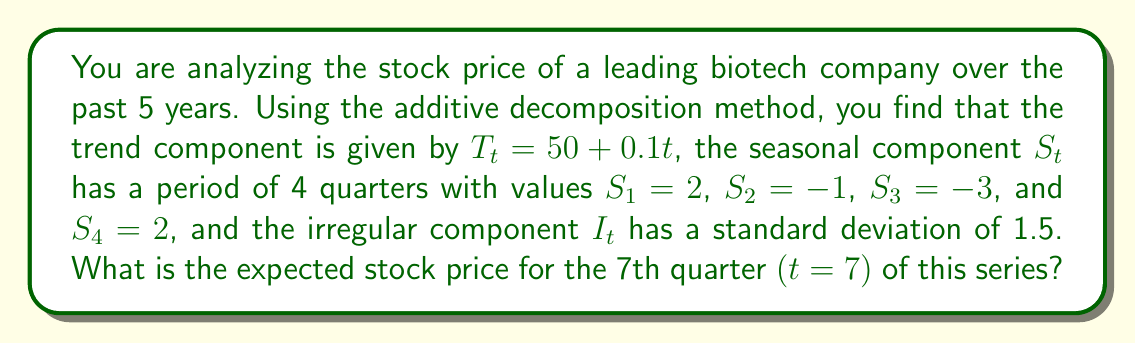Teach me how to tackle this problem. To solve this problem, we need to use the additive decomposition model for time series analysis. The additive model is given by:

$$Y_t = T_t + S_t + I_t$$

Where:
$Y_t$ is the observed value at time t
$T_t$ is the trend component
$S_t$ is the seasonal component
$I_t$ is the irregular component

Let's break down the solution step by step:

1) Trend component ($T_t$):
   Given $T_t = 50 + 0.1t$
   For t = 7, $T_7 = 50 + 0.1(7) = 50.7$

2) Seasonal component ($S_t$):
   The period is 4 quarters, so for the 7th quarter, we use the value for the 3rd quarter of the cycle:
   $S_7 = S_3 = -3$

3) Irregular component ($I_t$):
   We are given the standard deviation, but for the expected value, we use the mean of the irregular component, which is typically assumed to be zero in decomposition models.

4) Combining the components:
   $E[Y_7] = T_7 + S_7 + E[I_7]$
   $E[Y_7] = 50.7 + (-3) + 0 = 47.7$

Therefore, the expected stock price for the 7th quarter is 47.7.
Answer: $47.7 